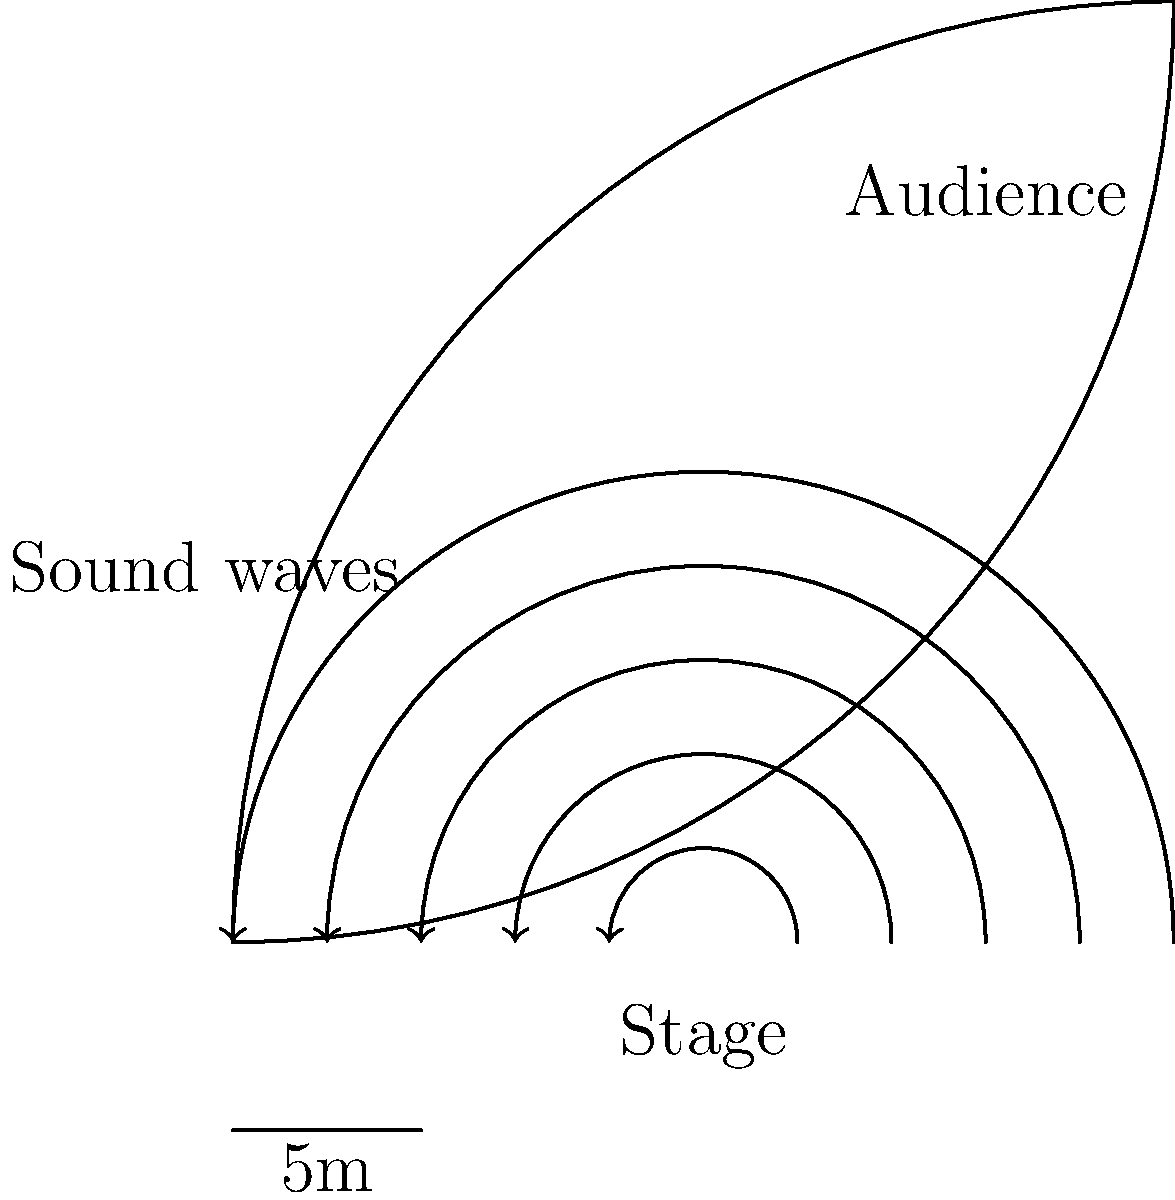In an ancient Assyrian amphitheater, the curved shape of the structure plays a crucial role in sound propagation. Based on the schematic, which shows sound waves emanating from the stage, how does the amphitheater's design enhance sound transmission to the audience? Consider the principles of wave reflection and focus. To understand how the amphitheater's design enhances sound transmission, we need to consider the following steps:

1. Wave propagation: Sound waves originate from the stage and travel outward in all directions.

2. Reflection: The curved surface of the amphitheater acts as a reflector for sound waves.

3. Focusing effect: Due to the concave shape of the amphitheater, reflected sound waves tend to converge rather than disperse.

4. Constructive interference: When reflected waves meet direct waves, they can reinforce each other through constructive interference, increasing sound intensity.

5. Reduced wave attenuation: The focused reflection minimizes the natural decrease in sound intensity that occurs with distance (inverse square law).

6. Even distribution: The curved design helps distribute sound more evenly across the audience area.

7. Reduced external noise: The structure's shape also helps to block external noise, improving the signal-to-noise ratio for the audience.

The combination of these factors results in enhanced sound transmission, allowing audience members to hear clearly even at greater distances from the stage. This design demonstrates the advanced understanding of acoustics in ancient Assyrian architecture.
Answer: The amphitheater's concave shape reflects and focuses sound waves, enhancing transmission to the audience through constructive interference and reduced attenuation. 